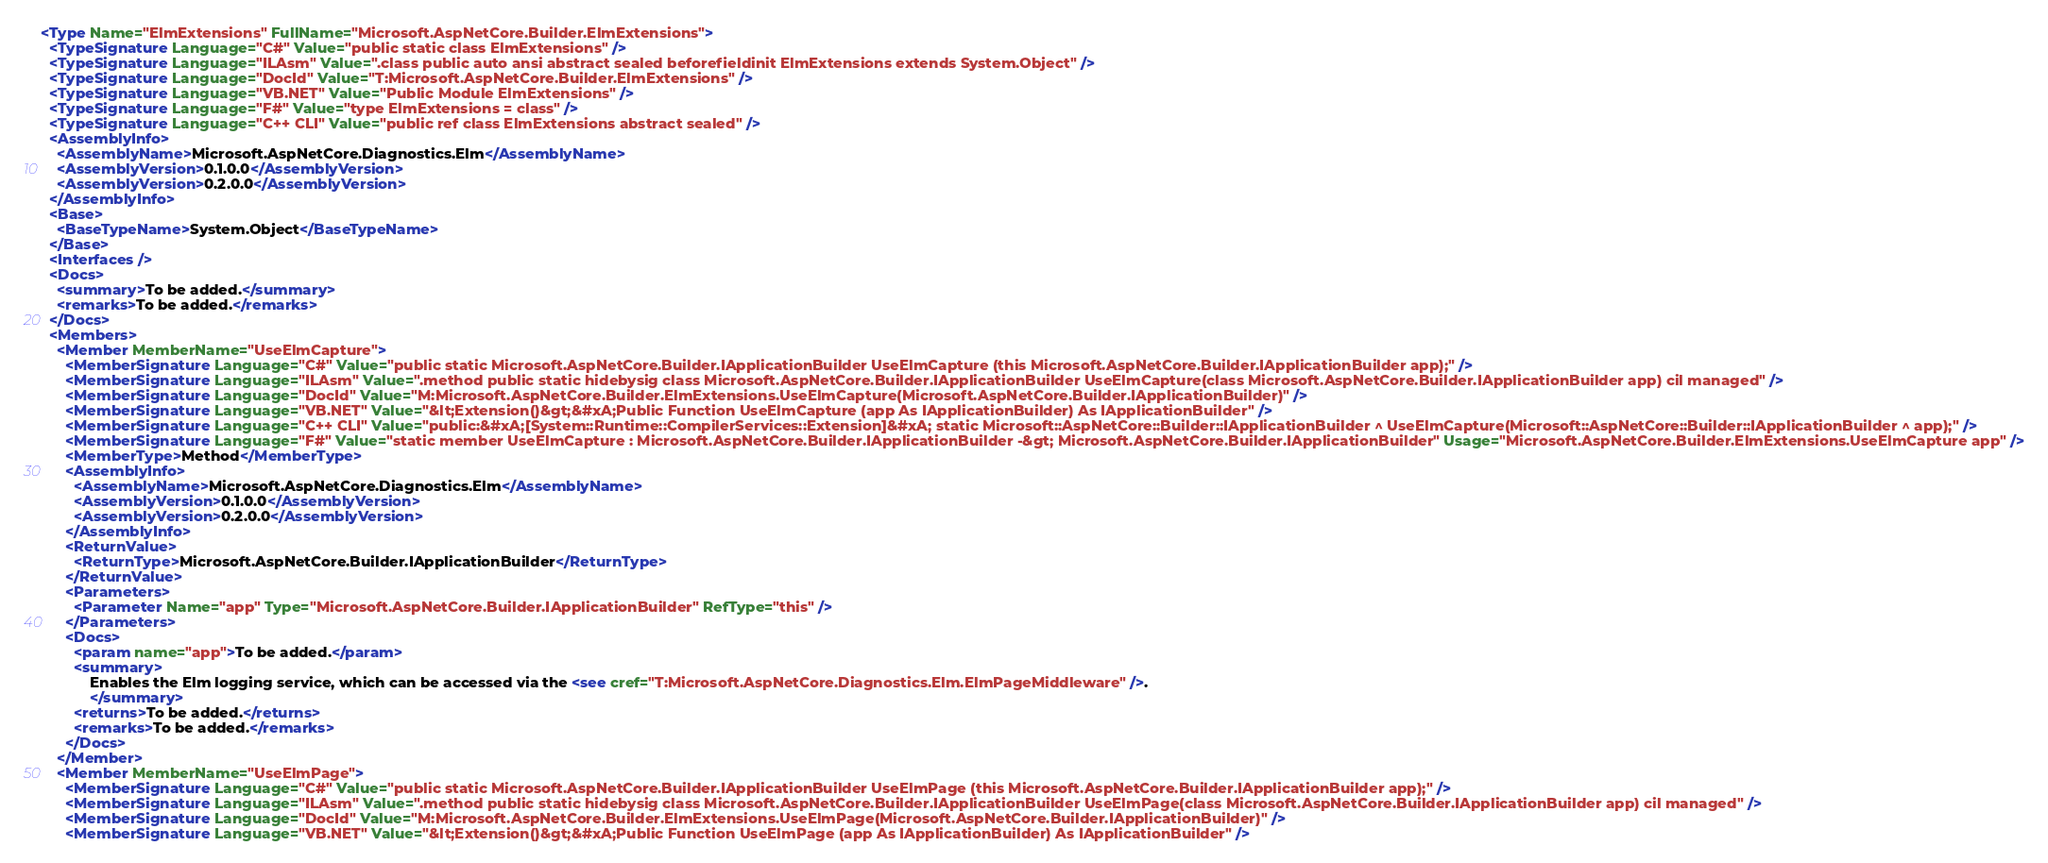Convert code to text. <code><loc_0><loc_0><loc_500><loc_500><_XML_><Type Name="ElmExtensions" FullName="Microsoft.AspNetCore.Builder.ElmExtensions">
  <TypeSignature Language="C#" Value="public static class ElmExtensions" />
  <TypeSignature Language="ILAsm" Value=".class public auto ansi abstract sealed beforefieldinit ElmExtensions extends System.Object" />
  <TypeSignature Language="DocId" Value="T:Microsoft.AspNetCore.Builder.ElmExtensions" />
  <TypeSignature Language="VB.NET" Value="Public Module ElmExtensions" />
  <TypeSignature Language="F#" Value="type ElmExtensions = class" />
  <TypeSignature Language="C++ CLI" Value="public ref class ElmExtensions abstract sealed" />
  <AssemblyInfo>
    <AssemblyName>Microsoft.AspNetCore.Diagnostics.Elm</AssemblyName>
    <AssemblyVersion>0.1.0.0</AssemblyVersion>
    <AssemblyVersion>0.2.0.0</AssemblyVersion>
  </AssemblyInfo>
  <Base>
    <BaseTypeName>System.Object</BaseTypeName>
  </Base>
  <Interfaces />
  <Docs>
    <summary>To be added.</summary>
    <remarks>To be added.</remarks>
  </Docs>
  <Members>
    <Member MemberName="UseElmCapture">
      <MemberSignature Language="C#" Value="public static Microsoft.AspNetCore.Builder.IApplicationBuilder UseElmCapture (this Microsoft.AspNetCore.Builder.IApplicationBuilder app);" />
      <MemberSignature Language="ILAsm" Value=".method public static hidebysig class Microsoft.AspNetCore.Builder.IApplicationBuilder UseElmCapture(class Microsoft.AspNetCore.Builder.IApplicationBuilder app) cil managed" />
      <MemberSignature Language="DocId" Value="M:Microsoft.AspNetCore.Builder.ElmExtensions.UseElmCapture(Microsoft.AspNetCore.Builder.IApplicationBuilder)" />
      <MemberSignature Language="VB.NET" Value="&lt;Extension()&gt;&#xA;Public Function UseElmCapture (app As IApplicationBuilder) As IApplicationBuilder" />
      <MemberSignature Language="C++ CLI" Value="public:&#xA;[System::Runtime::CompilerServices::Extension]&#xA; static Microsoft::AspNetCore::Builder::IApplicationBuilder ^ UseElmCapture(Microsoft::AspNetCore::Builder::IApplicationBuilder ^ app);" />
      <MemberSignature Language="F#" Value="static member UseElmCapture : Microsoft.AspNetCore.Builder.IApplicationBuilder -&gt; Microsoft.AspNetCore.Builder.IApplicationBuilder" Usage="Microsoft.AspNetCore.Builder.ElmExtensions.UseElmCapture app" />
      <MemberType>Method</MemberType>
      <AssemblyInfo>
        <AssemblyName>Microsoft.AspNetCore.Diagnostics.Elm</AssemblyName>
        <AssemblyVersion>0.1.0.0</AssemblyVersion>
        <AssemblyVersion>0.2.0.0</AssemblyVersion>
      </AssemblyInfo>
      <ReturnValue>
        <ReturnType>Microsoft.AspNetCore.Builder.IApplicationBuilder</ReturnType>
      </ReturnValue>
      <Parameters>
        <Parameter Name="app" Type="Microsoft.AspNetCore.Builder.IApplicationBuilder" RefType="this" />
      </Parameters>
      <Docs>
        <param name="app">To be added.</param>
        <summary>
            Enables the Elm logging service, which can be accessed via the <see cref="T:Microsoft.AspNetCore.Diagnostics.Elm.ElmPageMiddleware" />.
            </summary>
        <returns>To be added.</returns>
        <remarks>To be added.</remarks>
      </Docs>
    </Member>
    <Member MemberName="UseElmPage">
      <MemberSignature Language="C#" Value="public static Microsoft.AspNetCore.Builder.IApplicationBuilder UseElmPage (this Microsoft.AspNetCore.Builder.IApplicationBuilder app);" />
      <MemberSignature Language="ILAsm" Value=".method public static hidebysig class Microsoft.AspNetCore.Builder.IApplicationBuilder UseElmPage(class Microsoft.AspNetCore.Builder.IApplicationBuilder app) cil managed" />
      <MemberSignature Language="DocId" Value="M:Microsoft.AspNetCore.Builder.ElmExtensions.UseElmPage(Microsoft.AspNetCore.Builder.IApplicationBuilder)" />
      <MemberSignature Language="VB.NET" Value="&lt;Extension()&gt;&#xA;Public Function UseElmPage (app As IApplicationBuilder) As IApplicationBuilder" /></code> 